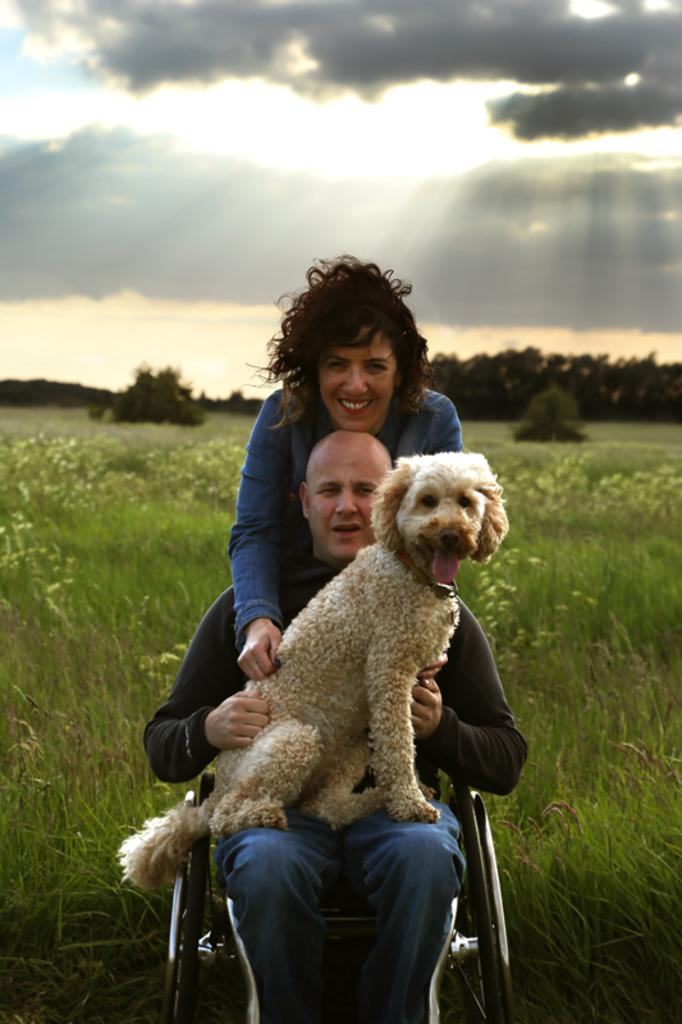What is the person in the image doing? The person is sitting on a wheelchair in the image. What is the person holding in the image? The person is holding a dog in the image. Can you describe the person behind the individual in the wheelchair? There is a lady behind the person in the wheelchair. What type of vegetation is visible in the image? There are plants and grass visible in the image. What part of the natural environment is visible in the image? The sky is visible in the image. What type of jar is being used to feed the turkey in the image? There is no jar or turkey present in the image. How does the society depicted in the image react to the person in the wheelchair? The image does not provide information about the society or how they react to the person in the wheelchair. 